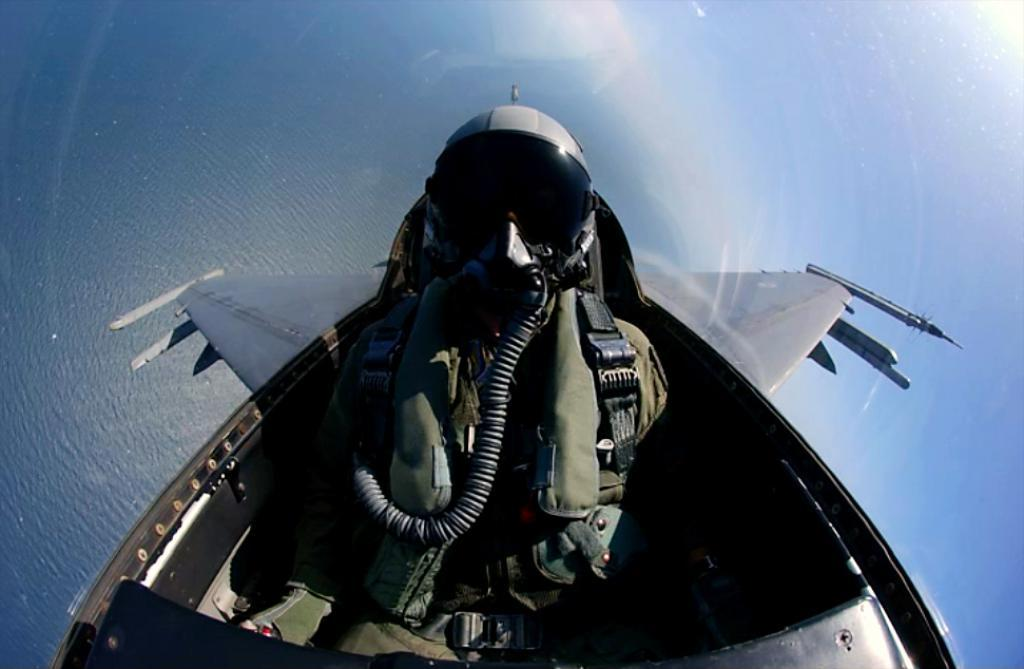What is the main subject of the image? The main subject of the image is a man. What is the man doing in the image? The man is sitting in the image. Where is the man located in the image? The man is in a plane. What type of skirt is the man wearing in the image? The man is not wearing a skirt in the image; he is in a plane. What kind of cake is being served on the plane in the image? There is no mention of a cake being served in the image; it only shows a man sitting in a plane. 